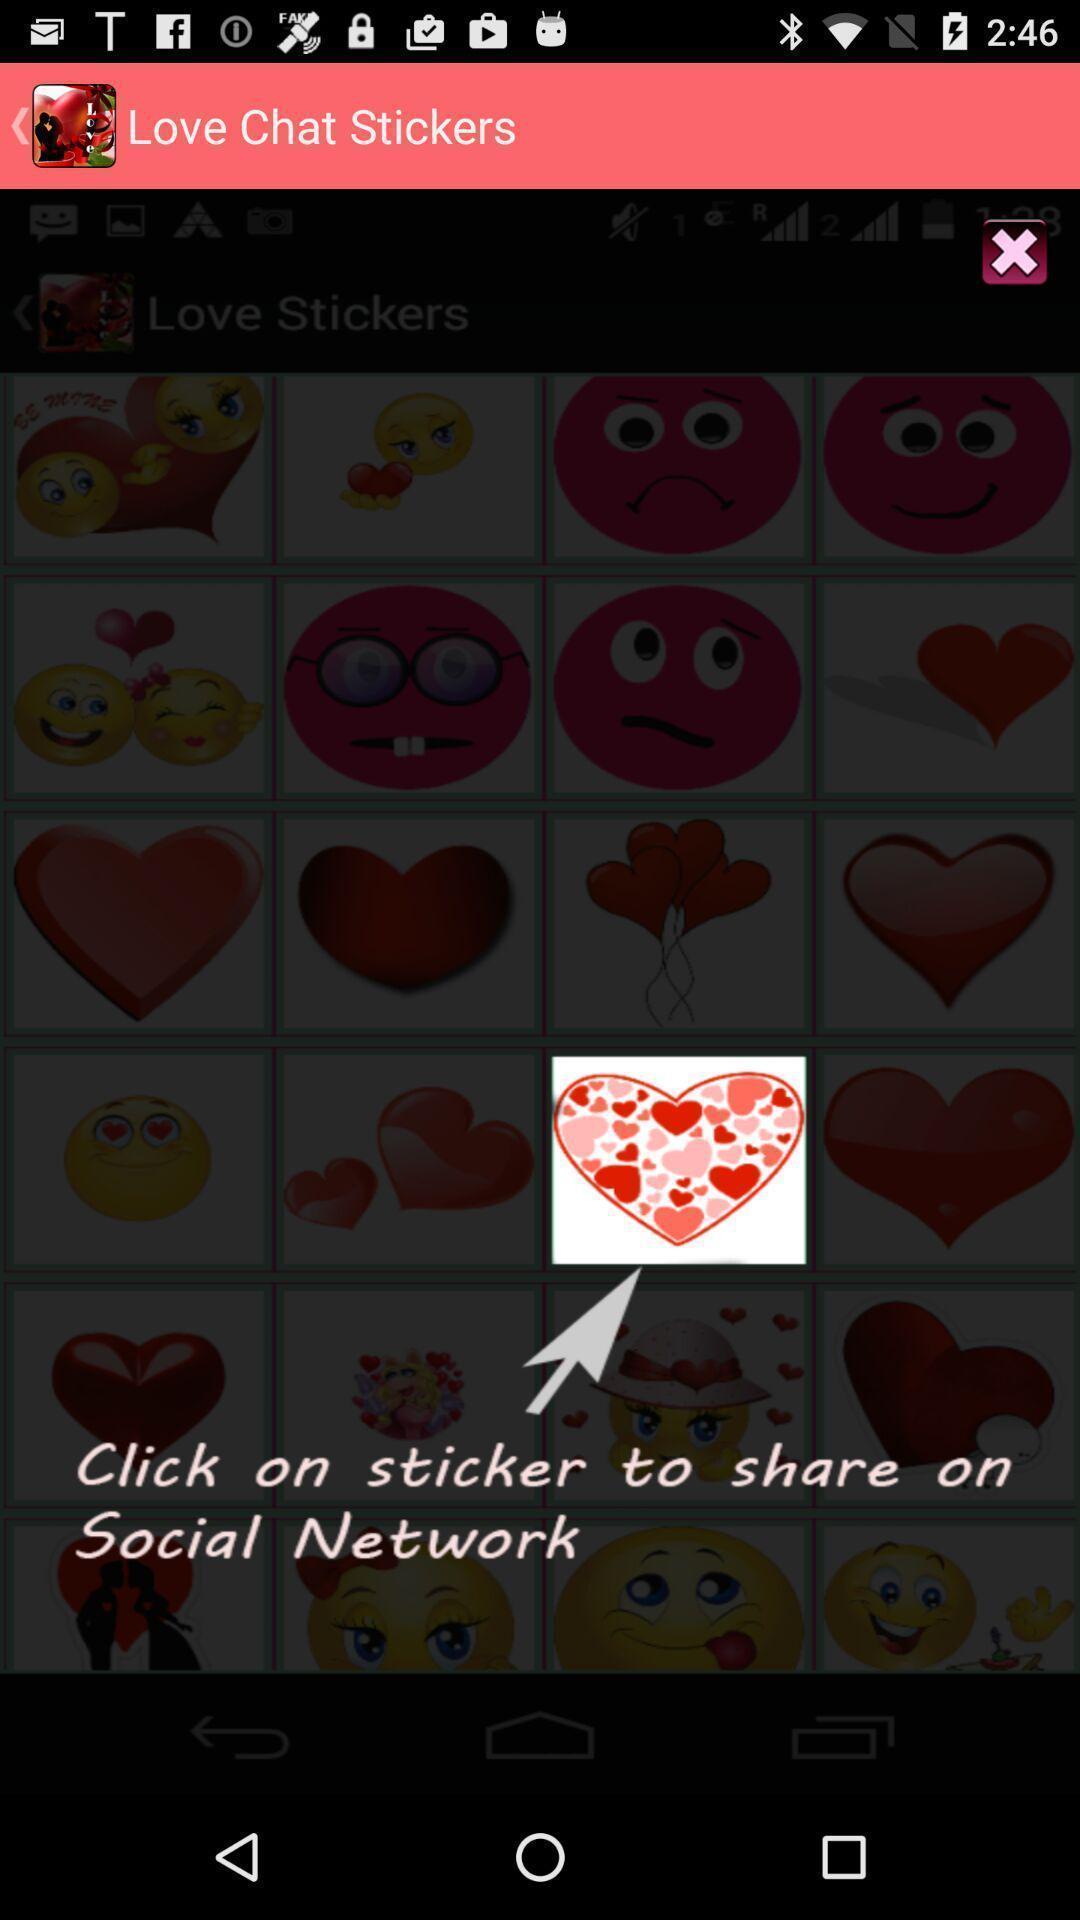Describe the key features of this screenshot. Screen shows to click on stickers in a chat app. 